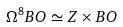Convert formula to latex. <formula><loc_0><loc_0><loc_500><loc_500>\Omega ^ { 8 } B O \simeq Z \times B O</formula> 